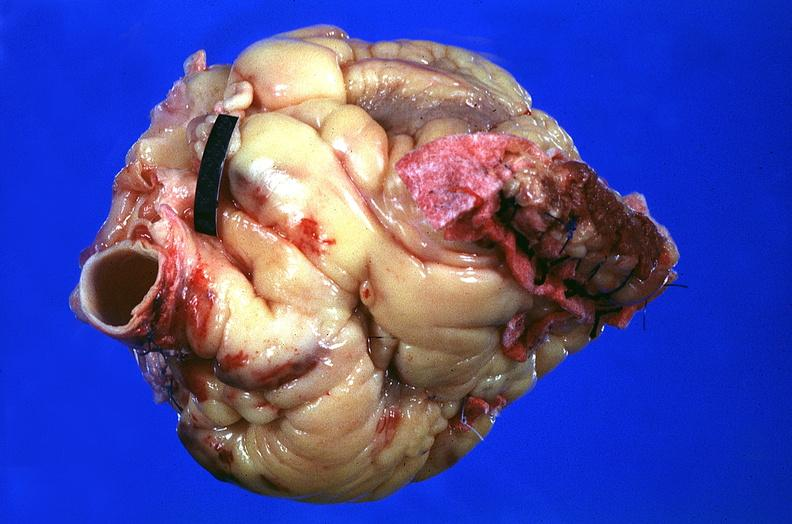where is this?
Answer the question using a single word or phrase. Heart 